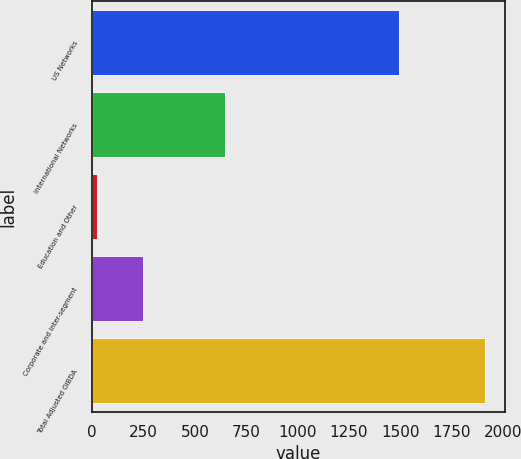<chart> <loc_0><loc_0><loc_500><loc_500><bar_chart><fcel>US Networks<fcel>International Networks<fcel>Education and Other<fcel>Corporate and inter-segment<fcel>Total Adjusted OIBDA<nl><fcel>1495<fcel>645<fcel>23<fcel>249<fcel>1914<nl></chart> 